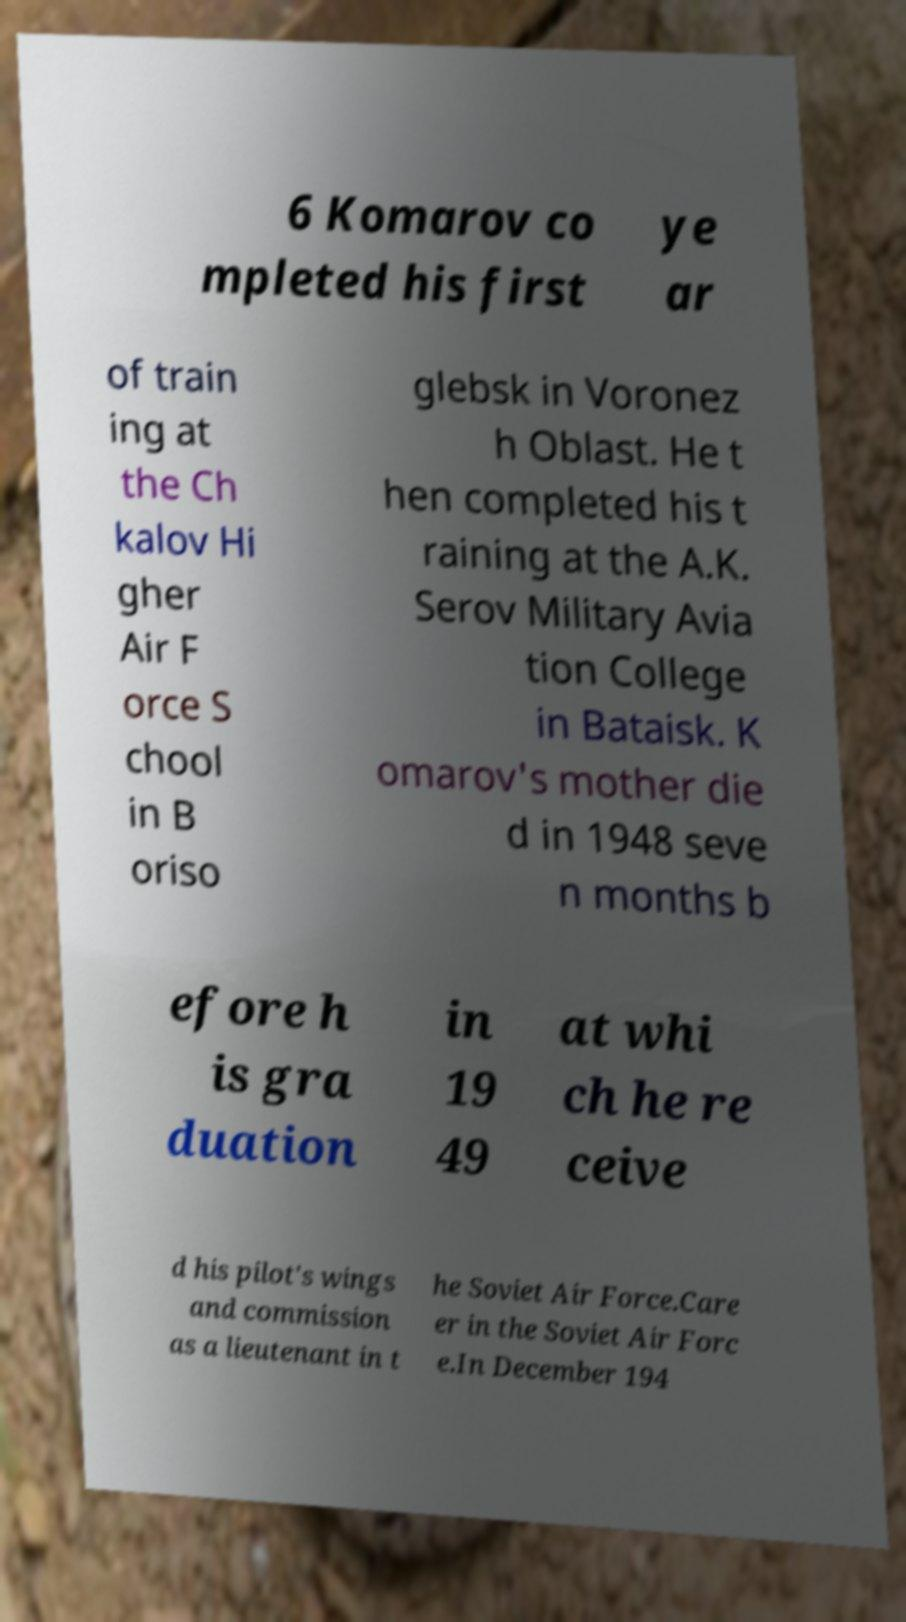What messages or text are displayed in this image? I need them in a readable, typed format. 6 Komarov co mpleted his first ye ar of train ing at the Ch kalov Hi gher Air F orce S chool in B oriso glebsk in Voronez h Oblast. He t hen completed his t raining at the A.K. Serov Military Avia tion College in Bataisk. K omarov's mother die d in 1948 seve n months b efore h is gra duation in 19 49 at whi ch he re ceive d his pilot's wings and commission as a lieutenant in t he Soviet Air Force.Care er in the Soviet Air Forc e.In December 194 